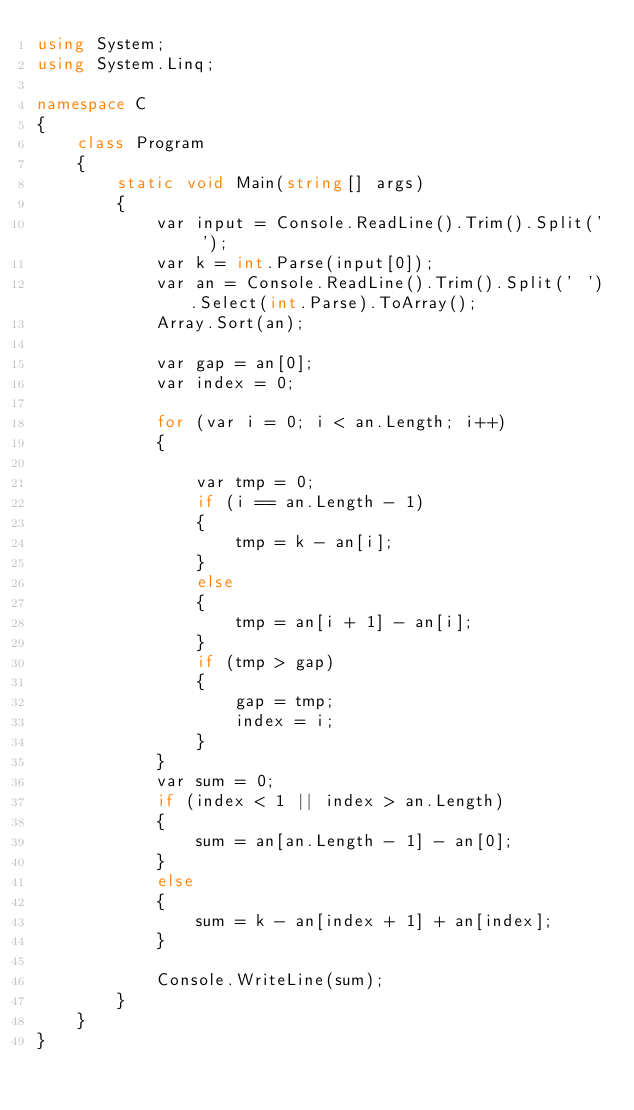Convert code to text. <code><loc_0><loc_0><loc_500><loc_500><_C#_>using System;
using System.Linq;

namespace C
{
    class Program
    {
        static void Main(string[] args)
        {
            var input = Console.ReadLine().Trim().Split(' ');
            var k = int.Parse(input[0]);
            var an = Console.ReadLine().Trim().Split(' ').Select(int.Parse).ToArray();
            Array.Sort(an);

            var gap = an[0];
            var index = 0;

            for (var i = 0; i < an.Length; i++)
            {

                var tmp = 0;
                if (i == an.Length - 1)
                {
                    tmp = k - an[i];
                }
                else
                {
                    tmp = an[i + 1] - an[i];
                }
                if (tmp > gap)
                {
                    gap = tmp;
                    index = i;
                }
            }
            var sum = 0;
            if (index < 1 || index > an.Length)
            {
                sum = an[an.Length - 1] - an[0];
            }
            else
            {
                sum = k - an[index + 1] + an[index];
            }

            Console.WriteLine(sum);
        }
    }
}
</code> 